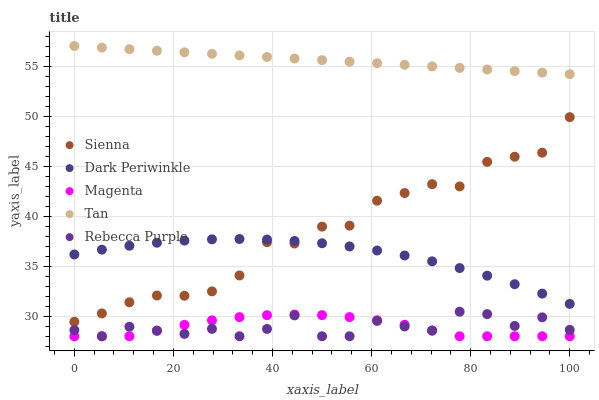Does Rebecca Purple have the minimum area under the curve?
Answer yes or no. Yes. Does Tan have the maximum area under the curve?
Answer yes or no. Yes. Does Magenta have the minimum area under the curve?
Answer yes or no. No. Does Magenta have the maximum area under the curve?
Answer yes or no. No. Is Tan the smoothest?
Answer yes or no. Yes. Is Rebecca Purple the roughest?
Answer yes or no. Yes. Is Magenta the smoothest?
Answer yes or no. No. Is Magenta the roughest?
Answer yes or no. No. Does Magenta have the lowest value?
Answer yes or no. Yes. Does Tan have the lowest value?
Answer yes or no. No. Does Tan have the highest value?
Answer yes or no. Yes. Does Magenta have the highest value?
Answer yes or no. No. Is Magenta less than Dark Periwinkle?
Answer yes or no. Yes. Is Tan greater than Magenta?
Answer yes or no. Yes. Does Magenta intersect Rebecca Purple?
Answer yes or no. Yes. Is Magenta less than Rebecca Purple?
Answer yes or no. No. Is Magenta greater than Rebecca Purple?
Answer yes or no. No. Does Magenta intersect Dark Periwinkle?
Answer yes or no. No. 